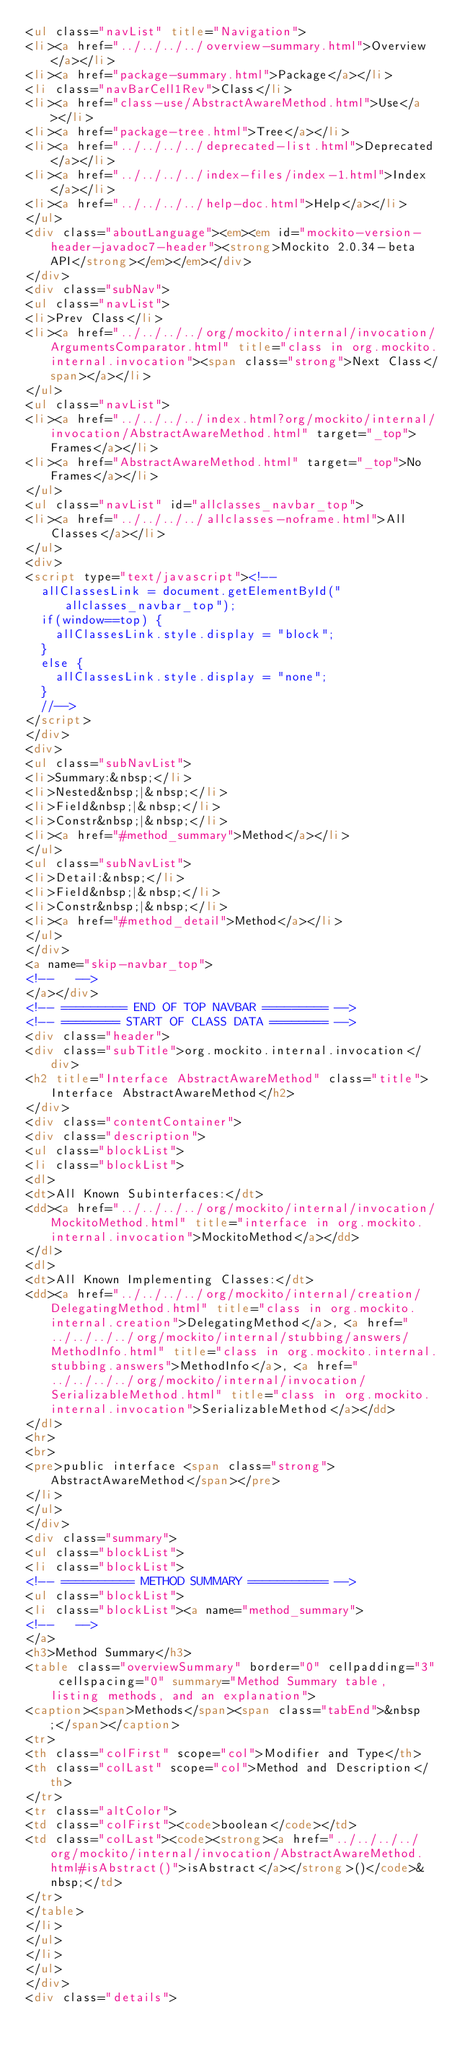<code> <loc_0><loc_0><loc_500><loc_500><_HTML_><ul class="navList" title="Navigation">
<li><a href="../../../../overview-summary.html">Overview</a></li>
<li><a href="package-summary.html">Package</a></li>
<li class="navBarCell1Rev">Class</li>
<li><a href="class-use/AbstractAwareMethod.html">Use</a></li>
<li><a href="package-tree.html">Tree</a></li>
<li><a href="../../../../deprecated-list.html">Deprecated</a></li>
<li><a href="../../../../index-files/index-1.html">Index</a></li>
<li><a href="../../../../help-doc.html">Help</a></li>
</ul>
<div class="aboutLanguage"><em><em id="mockito-version-header-javadoc7-header"><strong>Mockito 2.0.34-beta API</strong></em></em></div>
</div>
<div class="subNav">
<ul class="navList">
<li>Prev Class</li>
<li><a href="../../../../org/mockito/internal/invocation/ArgumentsComparator.html" title="class in org.mockito.internal.invocation"><span class="strong">Next Class</span></a></li>
</ul>
<ul class="navList">
<li><a href="../../../../index.html?org/mockito/internal/invocation/AbstractAwareMethod.html" target="_top">Frames</a></li>
<li><a href="AbstractAwareMethod.html" target="_top">No Frames</a></li>
</ul>
<ul class="navList" id="allclasses_navbar_top">
<li><a href="../../../../allclasses-noframe.html">All Classes</a></li>
</ul>
<div>
<script type="text/javascript"><!--
  allClassesLink = document.getElementById("allclasses_navbar_top");
  if(window==top) {
    allClassesLink.style.display = "block";
  }
  else {
    allClassesLink.style.display = "none";
  }
  //-->
</script>
</div>
<div>
<ul class="subNavList">
<li>Summary:&nbsp;</li>
<li>Nested&nbsp;|&nbsp;</li>
<li>Field&nbsp;|&nbsp;</li>
<li>Constr&nbsp;|&nbsp;</li>
<li><a href="#method_summary">Method</a></li>
</ul>
<ul class="subNavList">
<li>Detail:&nbsp;</li>
<li>Field&nbsp;|&nbsp;</li>
<li>Constr&nbsp;|&nbsp;</li>
<li><a href="#method_detail">Method</a></li>
</ul>
</div>
<a name="skip-navbar_top">
<!--   -->
</a></div>
<!-- ========= END OF TOP NAVBAR ========= -->
<!-- ======== START OF CLASS DATA ======== -->
<div class="header">
<div class="subTitle">org.mockito.internal.invocation</div>
<h2 title="Interface AbstractAwareMethod" class="title">Interface AbstractAwareMethod</h2>
</div>
<div class="contentContainer">
<div class="description">
<ul class="blockList">
<li class="blockList">
<dl>
<dt>All Known Subinterfaces:</dt>
<dd><a href="../../../../org/mockito/internal/invocation/MockitoMethod.html" title="interface in org.mockito.internal.invocation">MockitoMethod</a></dd>
</dl>
<dl>
<dt>All Known Implementing Classes:</dt>
<dd><a href="../../../../org/mockito/internal/creation/DelegatingMethod.html" title="class in org.mockito.internal.creation">DelegatingMethod</a>, <a href="../../../../org/mockito/internal/stubbing/answers/MethodInfo.html" title="class in org.mockito.internal.stubbing.answers">MethodInfo</a>, <a href="../../../../org/mockito/internal/invocation/SerializableMethod.html" title="class in org.mockito.internal.invocation">SerializableMethod</a></dd>
</dl>
<hr>
<br>
<pre>public interface <span class="strong">AbstractAwareMethod</span></pre>
</li>
</ul>
</div>
<div class="summary">
<ul class="blockList">
<li class="blockList">
<!-- ========== METHOD SUMMARY =========== -->
<ul class="blockList">
<li class="blockList"><a name="method_summary">
<!--   -->
</a>
<h3>Method Summary</h3>
<table class="overviewSummary" border="0" cellpadding="3" cellspacing="0" summary="Method Summary table, listing methods, and an explanation">
<caption><span>Methods</span><span class="tabEnd">&nbsp;</span></caption>
<tr>
<th class="colFirst" scope="col">Modifier and Type</th>
<th class="colLast" scope="col">Method and Description</th>
</tr>
<tr class="altColor">
<td class="colFirst"><code>boolean</code></td>
<td class="colLast"><code><strong><a href="../../../../org/mockito/internal/invocation/AbstractAwareMethod.html#isAbstract()">isAbstract</a></strong>()</code>&nbsp;</td>
</tr>
</table>
</li>
</ul>
</li>
</ul>
</div>
<div class="details"></code> 